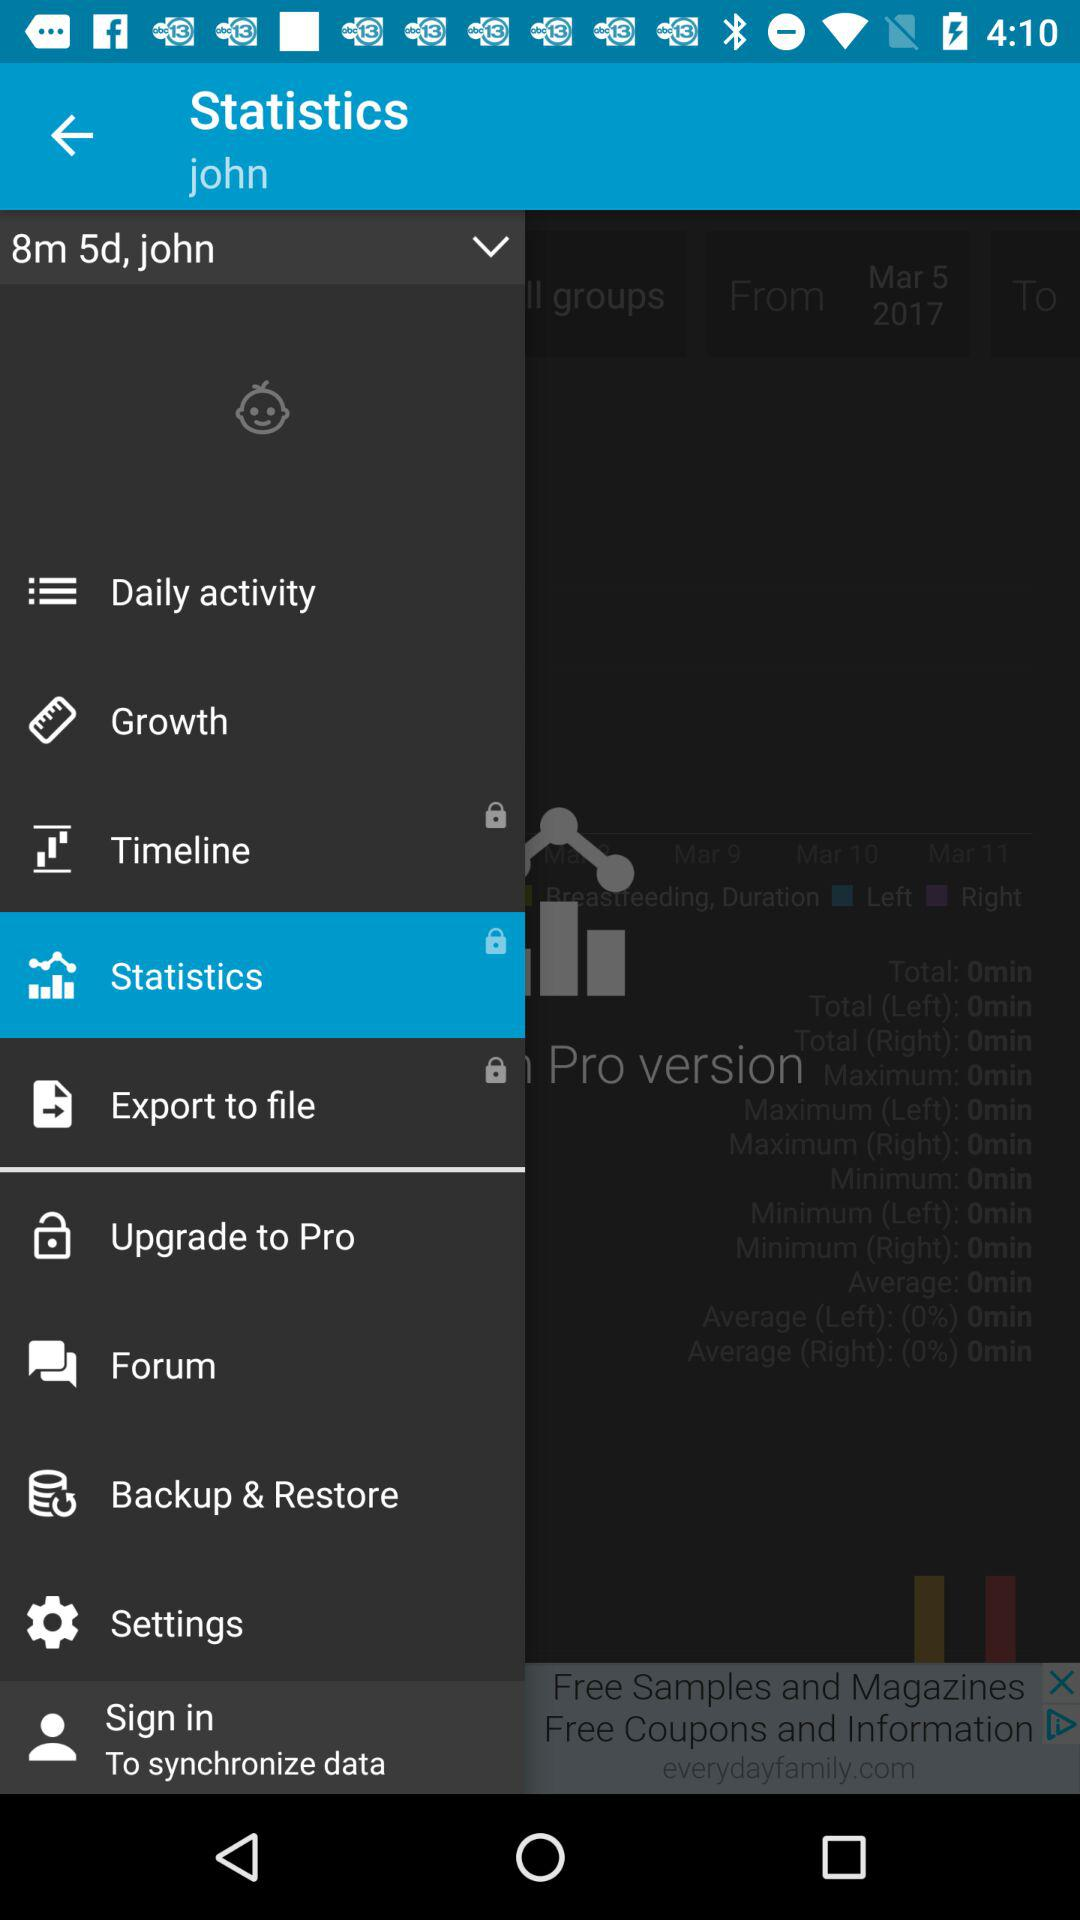From which date the statistics show the data?
When the provided information is insufficient, respond with <no answer>. <no answer> 